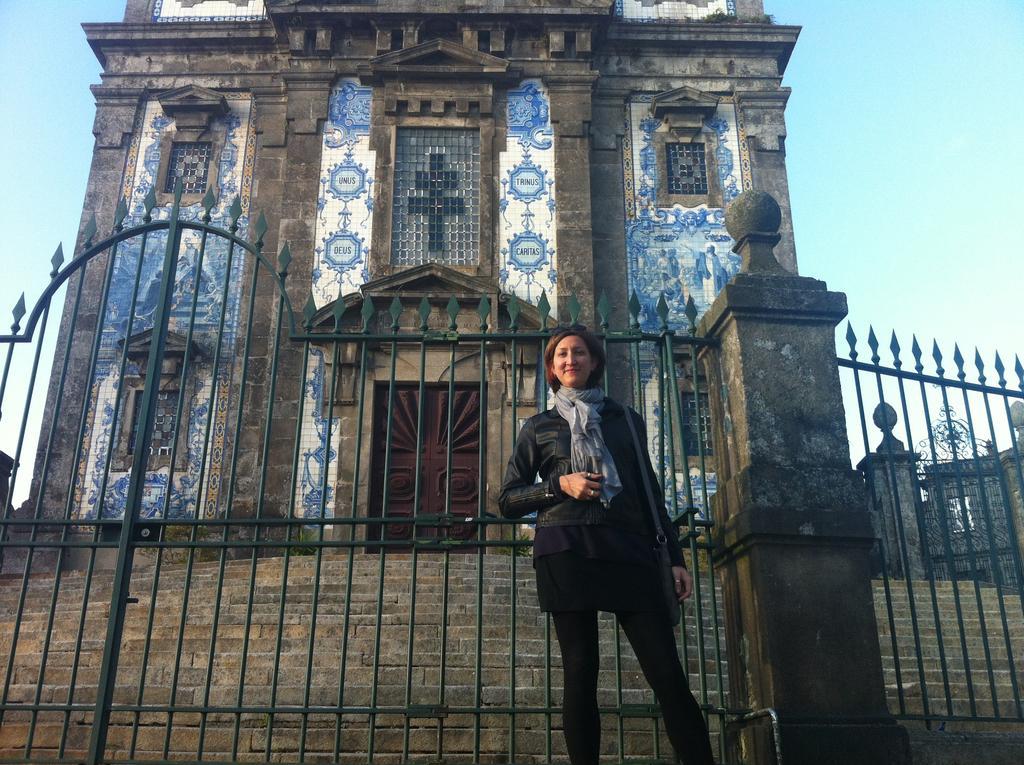Describe this image in one or two sentences. In this image I can see a person wearing black color dress is stunning. I can see the metal gate, a pillar, few stairs and a building which is black, brown, white and blue in color. In the background I can see the sky. 